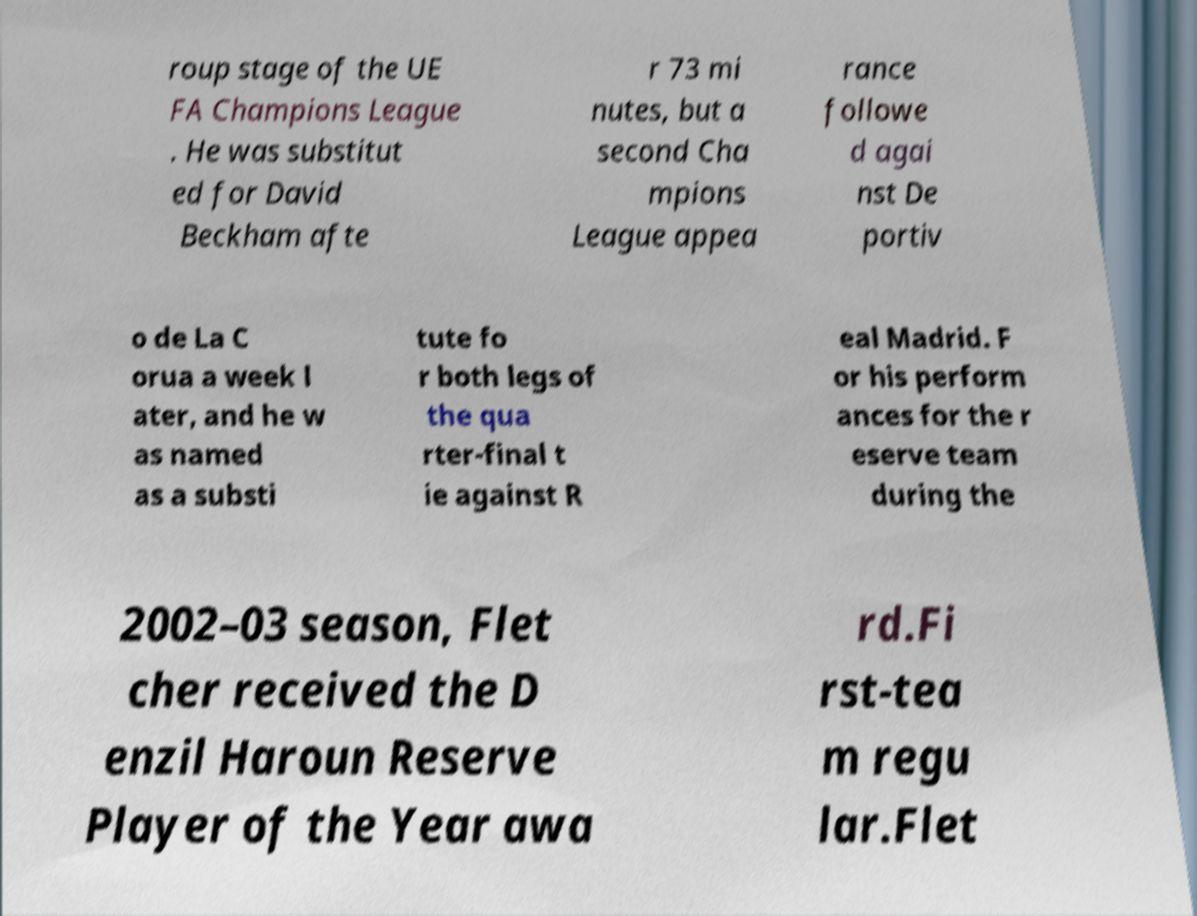For documentation purposes, I need the text within this image transcribed. Could you provide that? roup stage of the UE FA Champions League . He was substitut ed for David Beckham afte r 73 mi nutes, but a second Cha mpions League appea rance followe d agai nst De portiv o de La C orua a week l ater, and he w as named as a substi tute fo r both legs of the qua rter-final t ie against R eal Madrid. F or his perform ances for the r eserve team during the 2002–03 season, Flet cher received the D enzil Haroun Reserve Player of the Year awa rd.Fi rst-tea m regu lar.Flet 